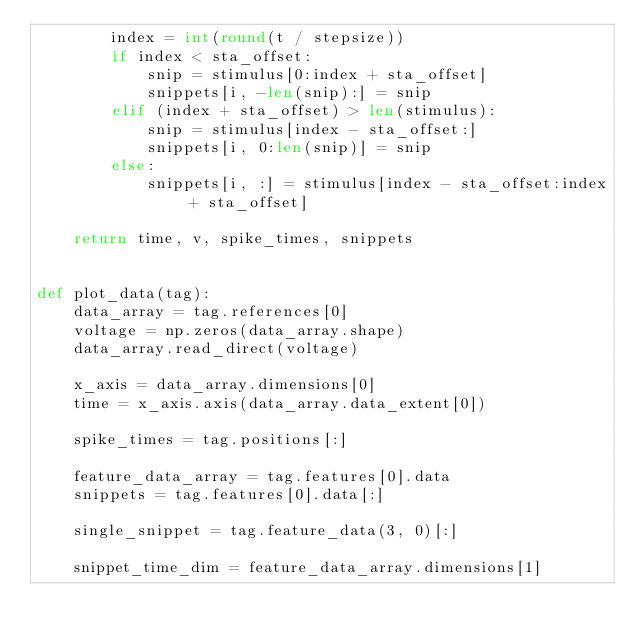<code> <loc_0><loc_0><loc_500><loc_500><_Python_>        index = int(round(t / stepsize))
        if index < sta_offset:
            snip = stimulus[0:index + sta_offset]
            snippets[i, -len(snip):] = snip
        elif (index + sta_offset) > len(stimulus):
            snip = stimulus[index - sta_offset:]
            snippets[i, 0:len(snip)] = snip
        else:
            snippets[i, :] = stimulus[index - sta_offset:index + sta_offset]

    return time, v, spike_times, snippets


def plot_data(tag):
    data_array = tag.references[0]
    voltage = np.zeros(data_array.shape)
    data_array.read_direct(voltage)

    x_axis = data_array.dimensions[0]
    time = x_axis.axis(data_array.data_extent[0])

    spike_times = tag.positions[:]

    feature_data_array = tag.features[0].data
    snippets = tag.features[0].data[:]

    single_snippet = tag.feature_data(3, 0)[:]

    snippet_time_dim = feature_data_array.dimensions[1]</code> 